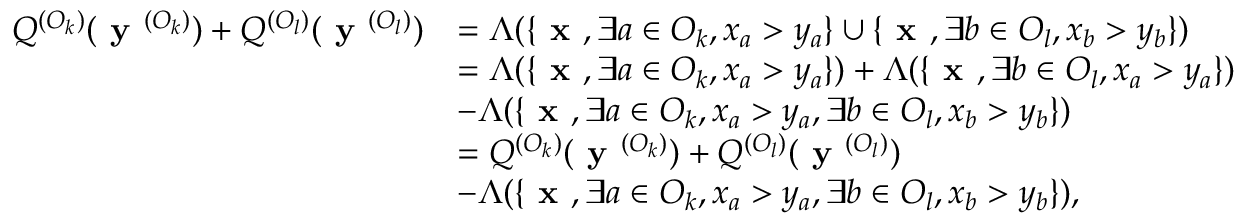<formula> <loc_0><loc_0><loc_500><loc_500>\begin{array} { r l } { Q ^ { ( O _ { k } ) } ( y ^ { ( O _ { k } ) } ) + Q ^ { ( O _ { l } ) } ( y ^ { ( O _ { l } ) } ) } & { = \Lambda ( \{ x , \exists a \in O _ { k } , x _ { a } > y _ { a } \} \cup \{ x , \exists b \in O _ { l } , x _ { b } > y _ { b } \} ) } \\ & { = \Lambda ( \{ x , \exists a \in O _ { k } , x _ { a } > y _ { a } \} ) + \Lambda ( \{ x , \exists b \in O _ { l } , x _ { a } > y _ { a } \} ) } \\ & { - \Lambda ( \{ x , \exists a \in O _ { k } , x _ { a } > y _ { a } , \exists b \in O _ { l } , x _ { b } > y _ { b } \} ) } \\ & { = Q ^ { ( O _ { k } ) } ( y ^ { ( O _ { k } ) } ) + Q ^ { ( O _ { l } ) } ( y ^ { ( O _ { l } ) } ) } \\ & { - \Lambda ( \{ x , \exists a \in O _ { k } , x _ { a } > y _ { a } , \exists b \in O _ { l } , x _ { b } > y _ { b } \} ) , } \end{array}</formula> 